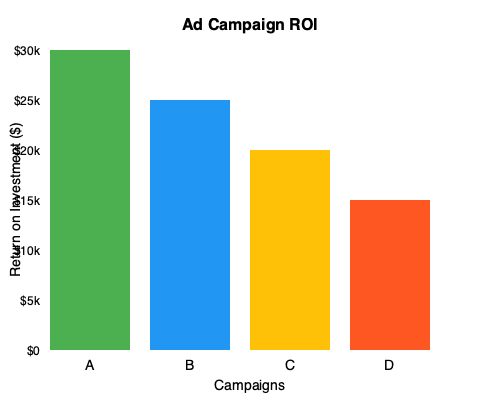Based on the bar graph showing the ROI for four ad campaigns (A, B, C, and D), which campaign had the highest ROI, and what was the difference in ROI between the highest and lowest performing campaigns? To solve this question, we need to follow these steps:

1. Identify the ROI for each campaign:
   Campaign A: $30,000
   Campaign B: $25,000
   Campaign C: $20,000
   Campaign D: $15,000

2. Determine the highest ROI:
   Campaign A has the highest bar, representing $30,000 ROI.

3. Determine the lowest ROI:
   Campaign D has the lowest bar, representing $15,000 ROI.

4. Calculate the difference between the highest and lowest ROI:
   $30,000 - $15,000 = $15,000

Therefore, Campaign A had the highest ROI, and the difference between the highest (Campaign A) and lowest (Campaign D) ROI is $15,000.
Answer: Campaign A; $15,000 